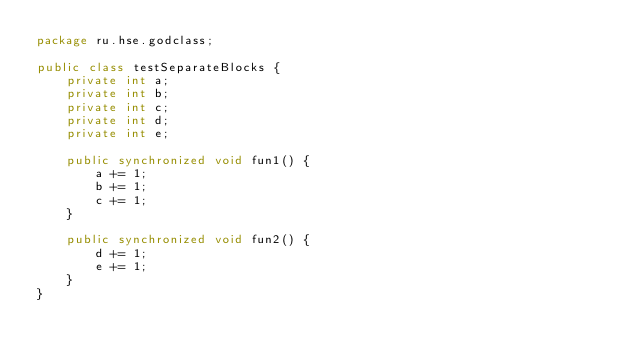Convert code to text. <code><loc_0><loc_0><loc_500><loc_500><_Java_>package ru.hse.godclass;

public class testSeparateBlocks {
    private int a;
    private int b;
    private int c;
    private int d;
    private int e;

    public synchronized void fun1() {
        a += 1;
        b += 1;
        c += 1;
    }

    public synchronized void fun2() {
        d += 1;
        e += 1;
    }
}</code> 